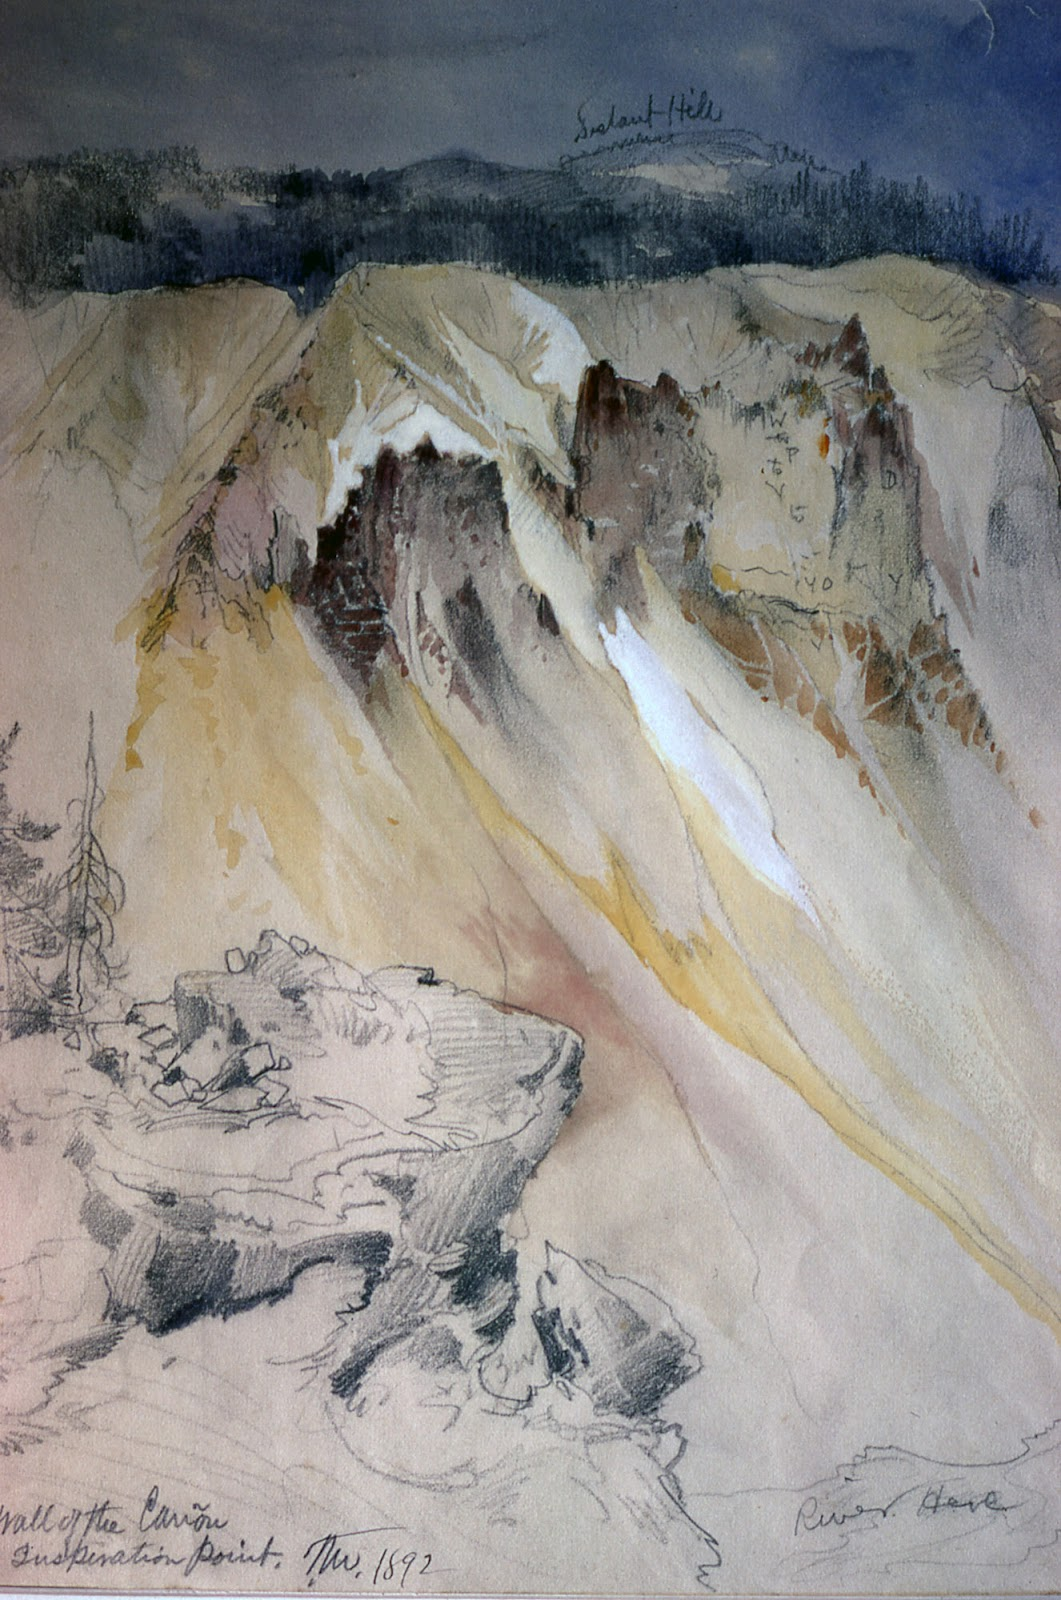Explain the visual content of the image in great detail. The image features a delicate watercolor and graphite painting capturing a striking mountainous landscape. It is signed by 'Ruskin' and dated 1872, suggesting it is a work by the famed art critic and watercolorist, John Ruskin. The scene portrays the grandeur of nature, likely depicting a canyon or cliffside, with rock formations colored in subtle shades of yellow, brown, gray, and white. These hues blend seamlessly, creating depth and texture. Annotations like 'Sulahnd Hills' and 'Valley of the Canyon' offer additional context. The sky, rendered in various shades of blue and gray, enhances the sense of serenity. Ruskin’s characteristic loose, sketchy style brings out the natural forms in a truthful and poetic manner, reflecting his philosophy of art. 